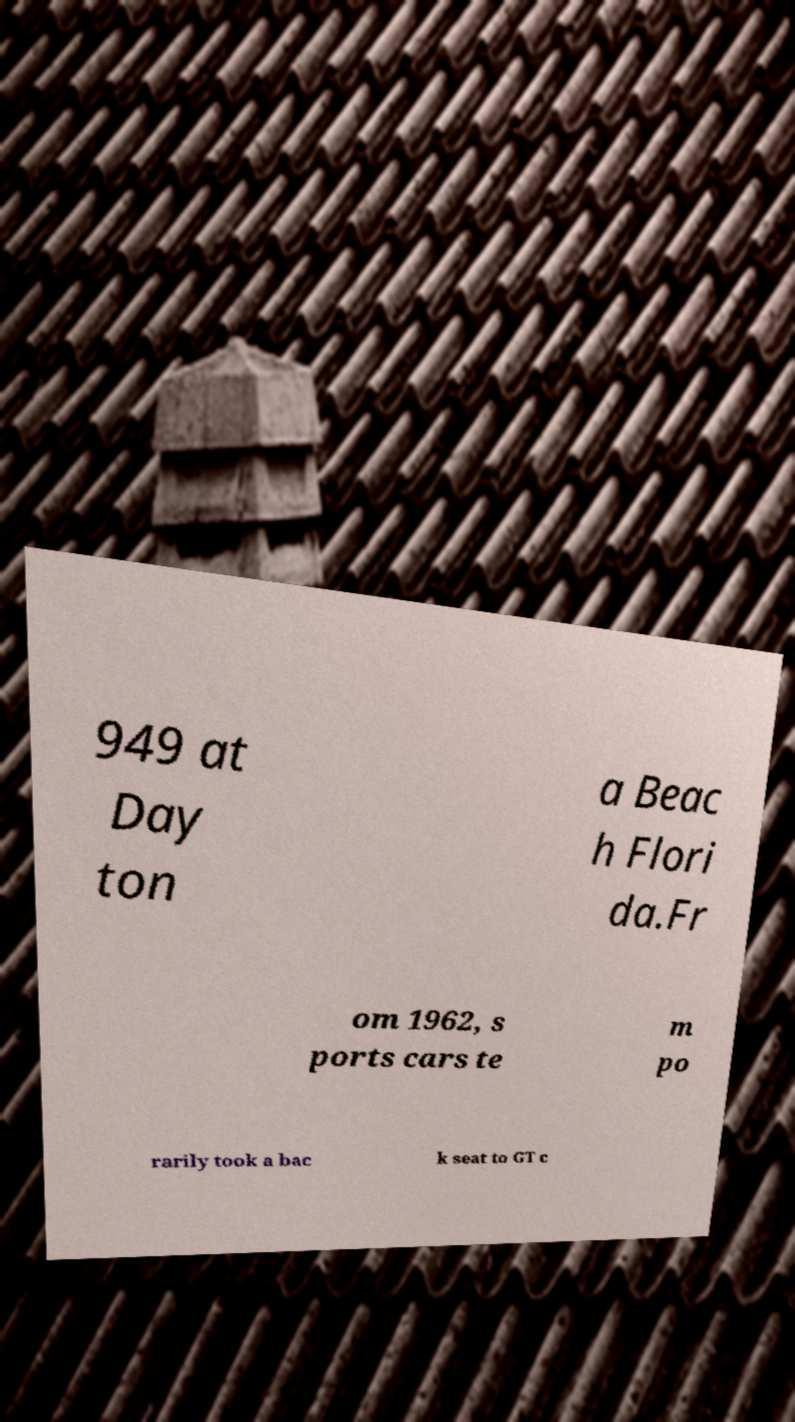For documentation purposes, I need the text within this image transcribed. Could you provide that? 949 at Day ton a Beac h Flori da.Fr om 1962, s ports cars te m po rarily took a bac k seat to GT c 